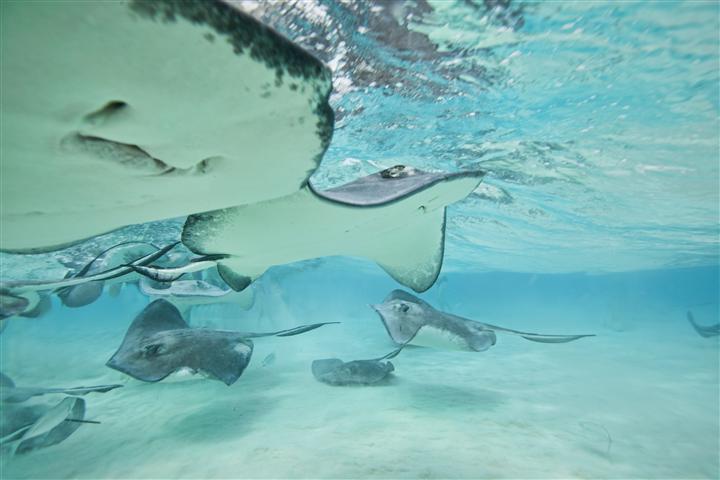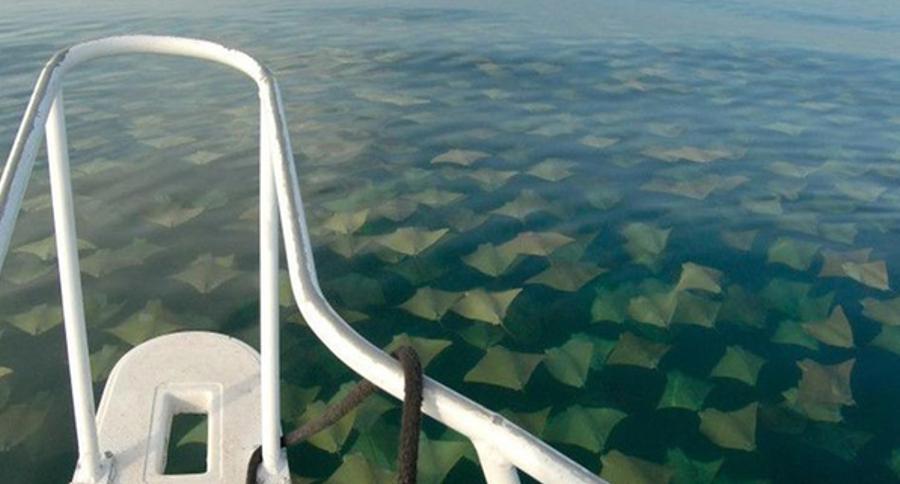The first image is the image on the left, the second image is the image on the right. For the images shown, is this caption "There is at least one human in the ocean in the left image." true? Answer yes or no. No. The first image is the image on the left, the second image is the image on the right. Assess this claim about the two images: "Each image contains people in a body of water with rays in it.". Correct or not? Answer yes or no. No. 